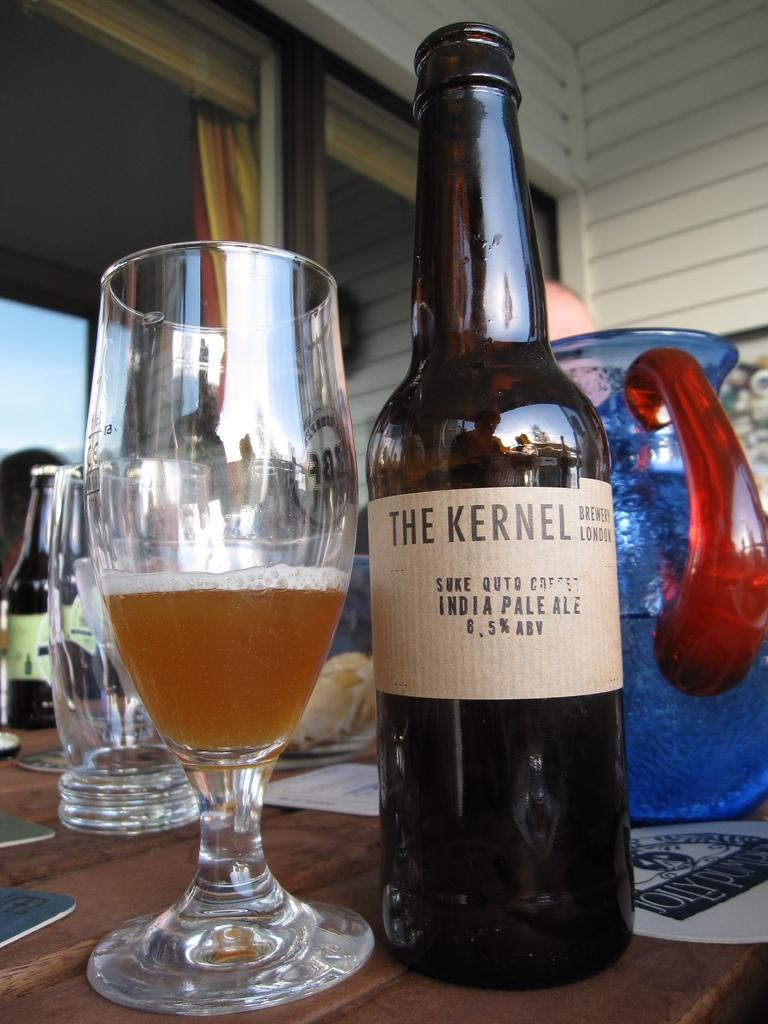What types of containers are on the table in the image? There are bottles, glasses, and jugs on the table in the image. What type of chain can be seen hanging from the ceiling in the image? There is no chain present in the image; it only features bottles, glasses, and jugs on a table. 